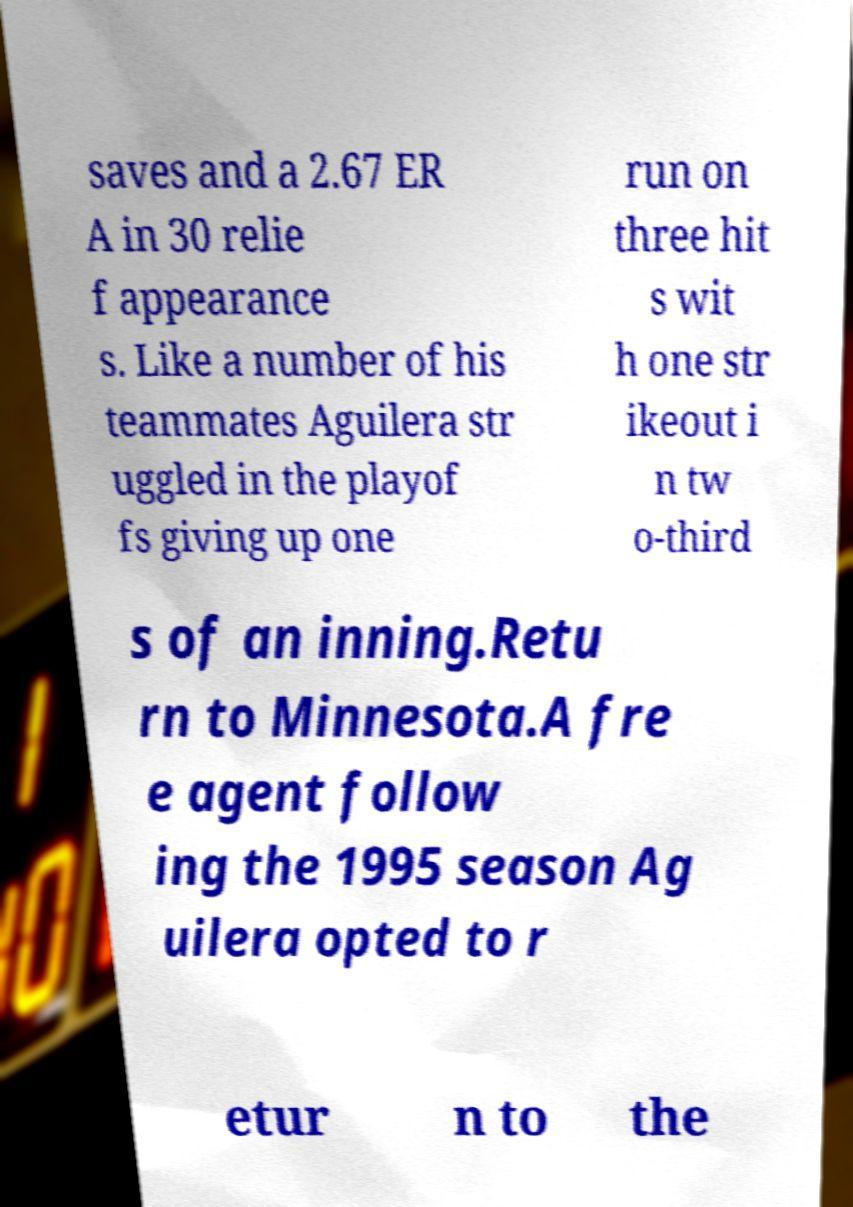Could you assist in decoding the text presented in this image and type it out clearly? saves and a 2.67 ER A in 30 relie f appearance s. Like a number of his teammates Aguilera str uggled in the playof fs giving up one run on three hit s wit h one str ikeout i n tw o-third s of an inning.Retu rn to Minnesota.A fre e agent follow ing the 1995 season Ag uilera opted to r etur n to the 